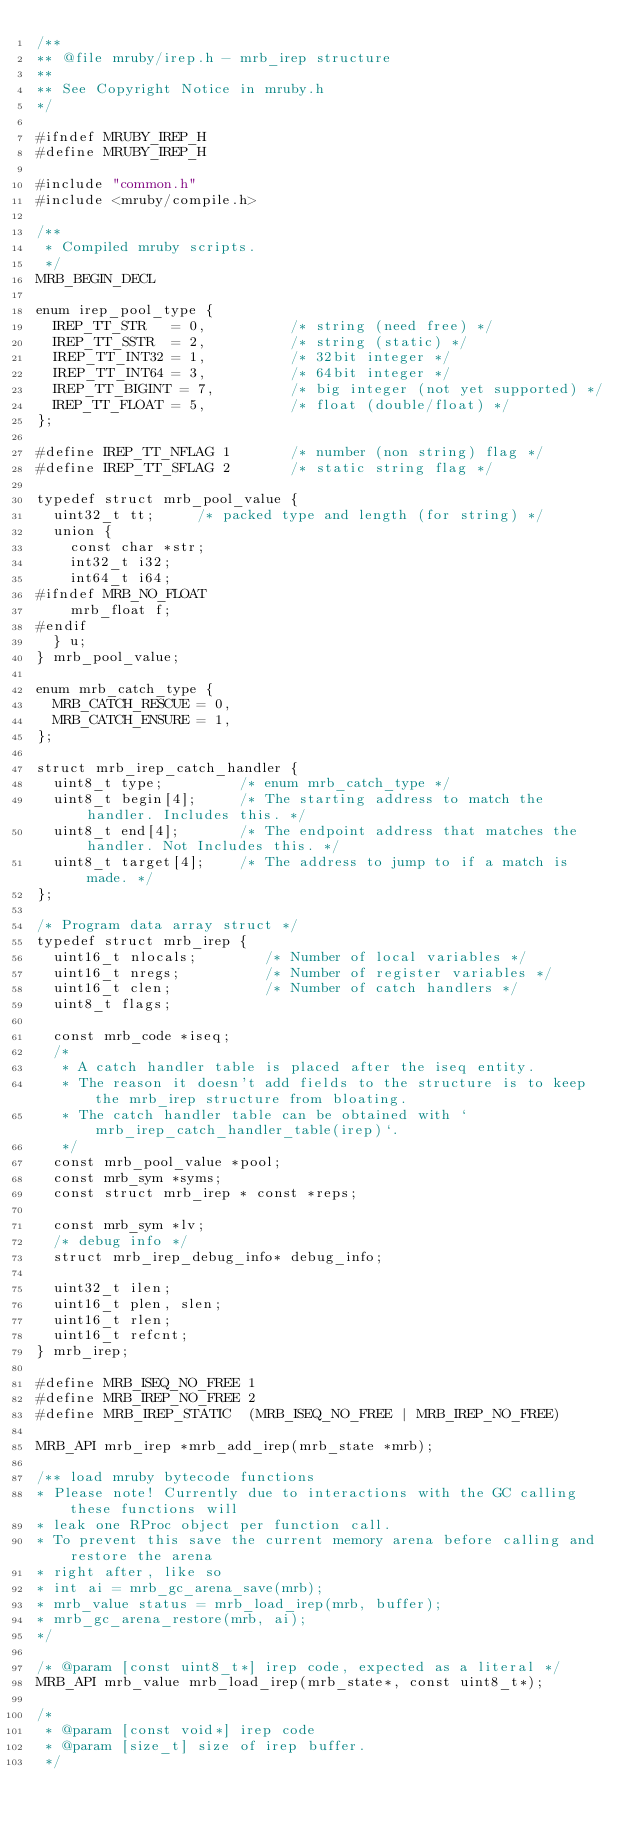Convert code to text. <code><loc_0><loc_0><loc_500><loc_500><_C_>/**
** @file mruby/irep.h - mrb_irep structure
**
** See Copyright Notice in mruby.h
*/

#ifndef MRUBY_IREP_H
#define MRUBY_IREP_H

#include "common.h"
#include <mruby/compile.h>

/**
 * Compiled mruby scripts.
 */
MRB_BEGIN_DECL

enum irep_pool_type {
  IREP_TT_STR   = 0,          /* string (need free) */
  IREP_TT_SSTR  = 2,          /* string (static) */
  IREP_TT_INT32 = 1,          /* 32bit integer */
  IREP_TT_INT64 = 3,          /* 64bit integer */
  IREP_TT_BIGINT = 7,         /* big integer (not yet supported) */
  IREP_TT_FLOAT = 5,          /* float (double/float) */
};

#define IREP_TT_NFLAG 1       /* number (non string) flag */
#define IREP_TT_SFLAG 2       /* static string flag */

typedef struct mrb_pool_value {
  uint32_t tt;     /* packed type and length (for string) */
  union {
    const char *str;
    int32_t i32;
    int64_t i64;
#ifndef MRB_NO_FLOAT
    mrb_float f;
#endif
  } u;
} mrb_pool_value;

enum mrb_catch_type {
  MRB_CATCH_RESCUE = 0,
  MRB_CATCH_ENSURE = 1,
};

struct mrb_irep_catch_handler {
  uint8_t type;         /* enum mrb_catch_type */
  uint8_t begin[4];     /* The starting address to match the handler. Includes this. */
  uint8_t end[4];       /* The endpoint address that matches the handler. Not Includes this. */
  uint8_t target[4];    /* The address to jump to if a match is made. */
};

/* Program data array struct */
typedef struct mrb_irep {
  uint16_t nlocals;        /* Number of local variables */
  uint16_t nregs;          /* Number of register variables */
  uint16_t clen;           /* Number of catch handlers */
  uint8_t flags;

  const mrb_code *iseq;
  /*
   * A catch handler table is placed after the iseq entity.
   * The reason it doesn't add fields to the structure is to keep the mrb_irep structure from bloating.
   * The catch handler table can be obtained with `mrb_irep_catch_handler_table(irep)`.
   */
  const mrb_pool_value *pool;
  const mrb_sym *syms;
  const struct mrb_irep * const *reps;

  const mrb_sym *lv;
  /* debug info */
  struct mrb_irep_debug_info* debug_info;

  uint32_t ilen;
  uint16_t plen, slen;
  uint16_t rlen;
  uint16_t refcnt;
} mrb_irep;

#define MRB_ISEQ_NO_FREE 1
#define MRB_IREP_NO_FREE 2
#define MRB_IREP_STATIC  (MRB_ISEQ_NO_FREE | MRB_IREP_NO_FREE)

MRB_API mrb_irep *mrb_add_irep(mrb_state *mrb);

/** load mruby bytecode functions
* Please note! Currently due to interactions with the GC calling these functions will
* leak one RProc object per function call.
* To prevent this save the current memory arena before calling and restore the arena
* right after, like so
* int ai = mrb_gc_arena_save(mrb);
* mrb_value status = mrb_load_irep(mrb, buffer);
* mrb_gc_arena_restore(mrb, ai);
*/

/* @param [const uint8_t*] irep code, expected as a literal */
MRB_API mrb_value mrb_load_irep(mrb_state*, const uint8_t*);

/*
 * @param [const void*] irep code
 * @param [size_t] size of irep buffer.
 */</code> 